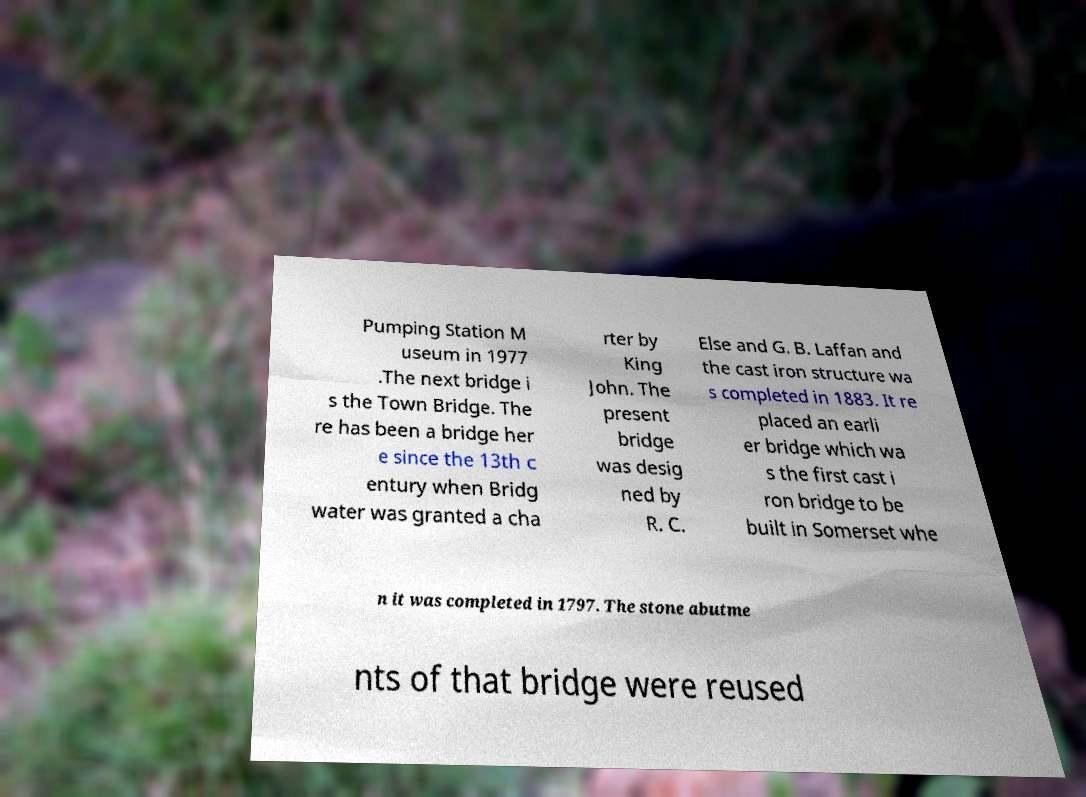Could you assist in decoding the text presented in this image and type it out clearly? Pumping Station M useum in 1977 .The next bridge i s the Town Bridge. The re has been a bridge her e since the 13th c entury when Bridg water was granted a cha rter by King John. The present bridge was desig ned by R. C. Else and G. B. Laffan and the cast iron structure wa s completed in 1883. It re placed an earli er bridge which wa s the first cast i ron bridge to be built in Somerset whe n it was completed in 1797. The stone abutme nts of that bridge were reused 